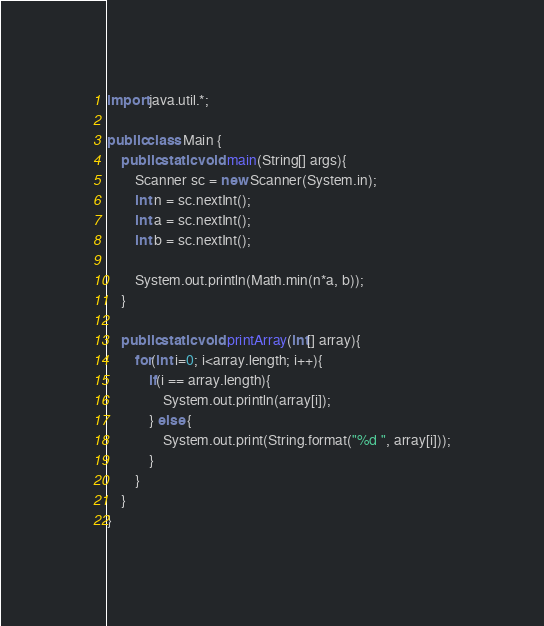<code> <loc_0><loc_0><loc_500><loc_500><_Java_>import java.util.*;

public class Main {
    public static void main(String[] args){
        Scanner sc = new Scanner(System.in);
        int n = sc.nextInt();
        int a = sc.nextInt();
        int b = sc.nextInt();

        System.out.println(Math.min(n*a, b));
    }

    public static void printArray(int[] array){
        for(int i=0; i<array.length; i++){
            if(i == array.length){
                System.out.println(array[i]);
            } else {
                System.out.print(String.format("%d ", array[i]));
            }
        }
    }
}
</code> 